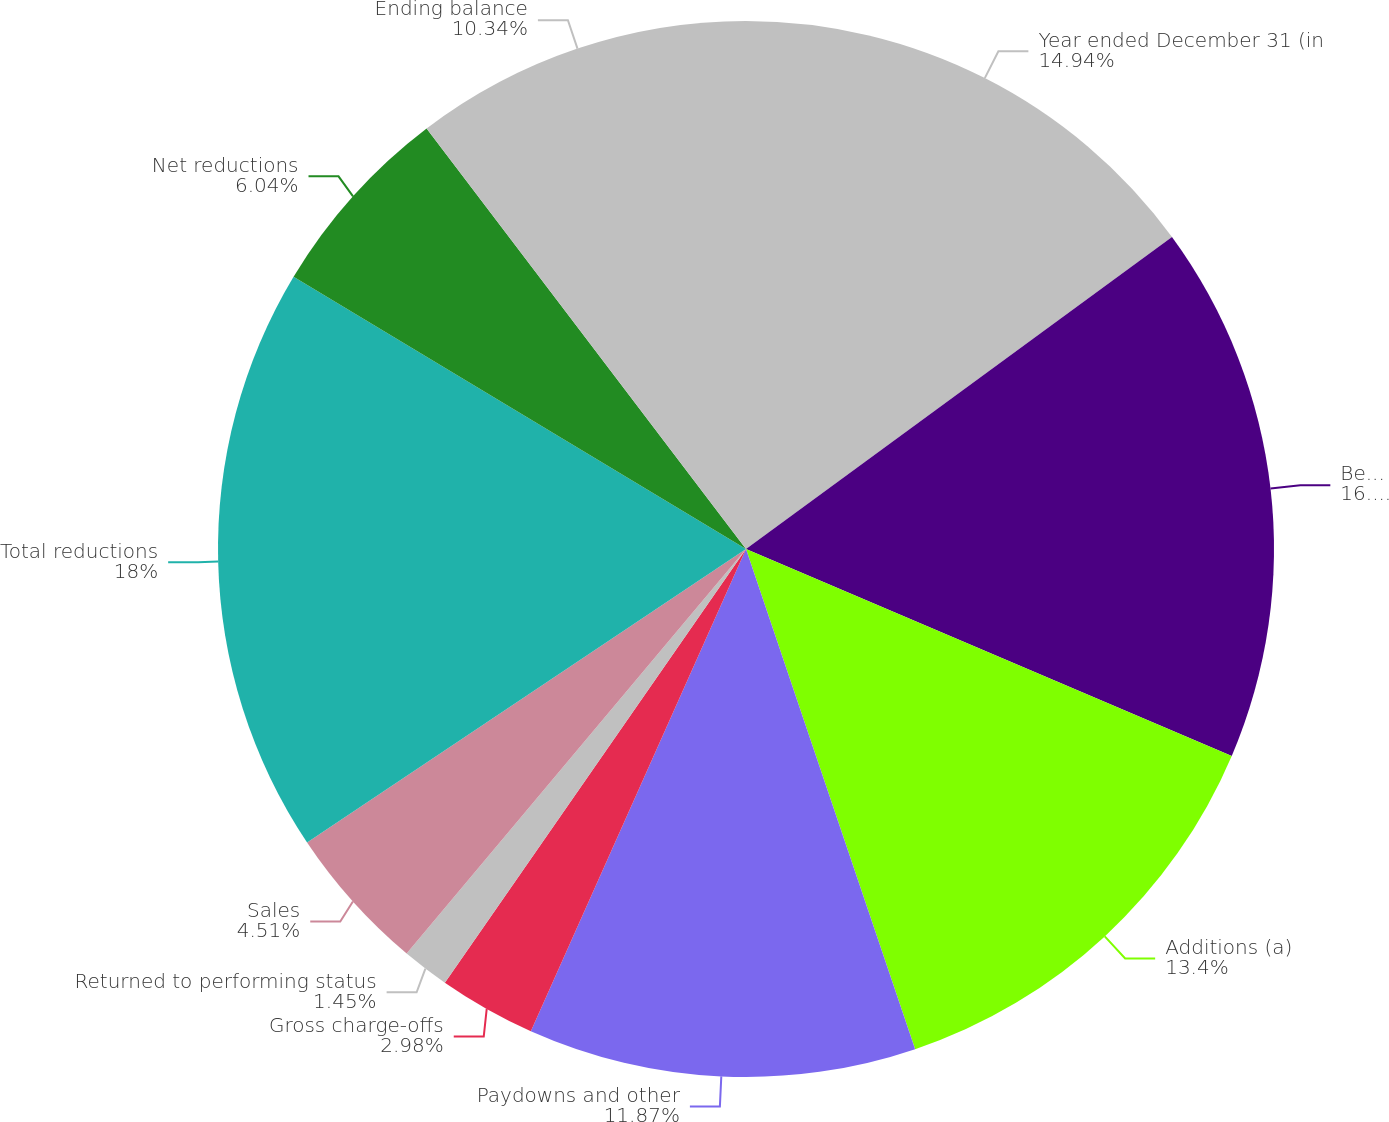<chart> <loc_0><loc_0><loc_500><loc_500><pie_chart><fcel>Year ended December 31 (in<fcel>Beginning balance<fcel>Additions (a)<fcel>Paydowns and other<fcel>Gross charge-offs<fcel>Returned to performing status<fcel>Sales<fcel>Total reductions<fcel>Net reductions<fcel>Ending balance<nl><fcel>14.94%<fcel>16.47%<fcel>13.4%<fcel>11.87%<fcel>2.98%<fcel>1.45%<fcel>4.51%<fcel>18.0%<fcel>6.04%<fcel>10.34%<nl></chart> 